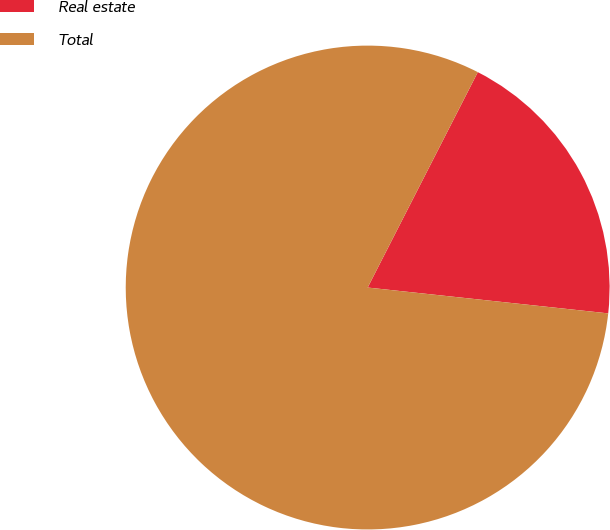Convert chart to OTSL. <chart><loc_0><loc_0><loc_500><loc_500><pie_chart><fcel>Real estate<fcel>Total<nl><fcel>19.18%<fcel>80.82%<nl></chart> 